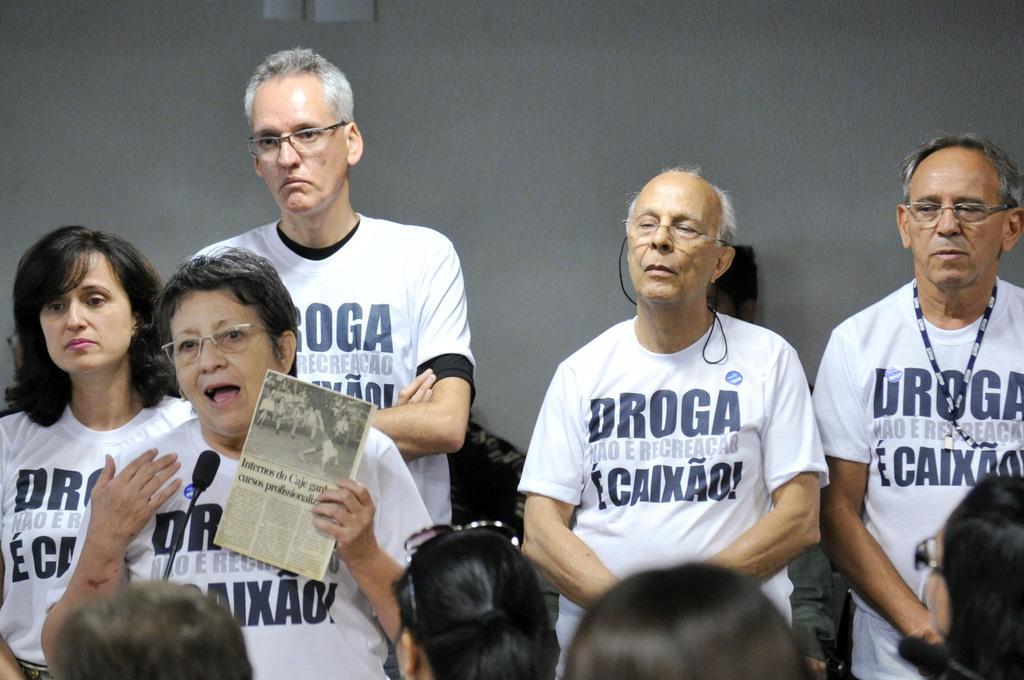Describe this image in one or two sentences. Here I can see few people are wearing white color t-shirts and standing. On the left side a person is holding a newspaper in the hand and speaking on the mike. At the bottom of the image I can see few people are facing towards the people who are standing. In the background, I can see a wall. 